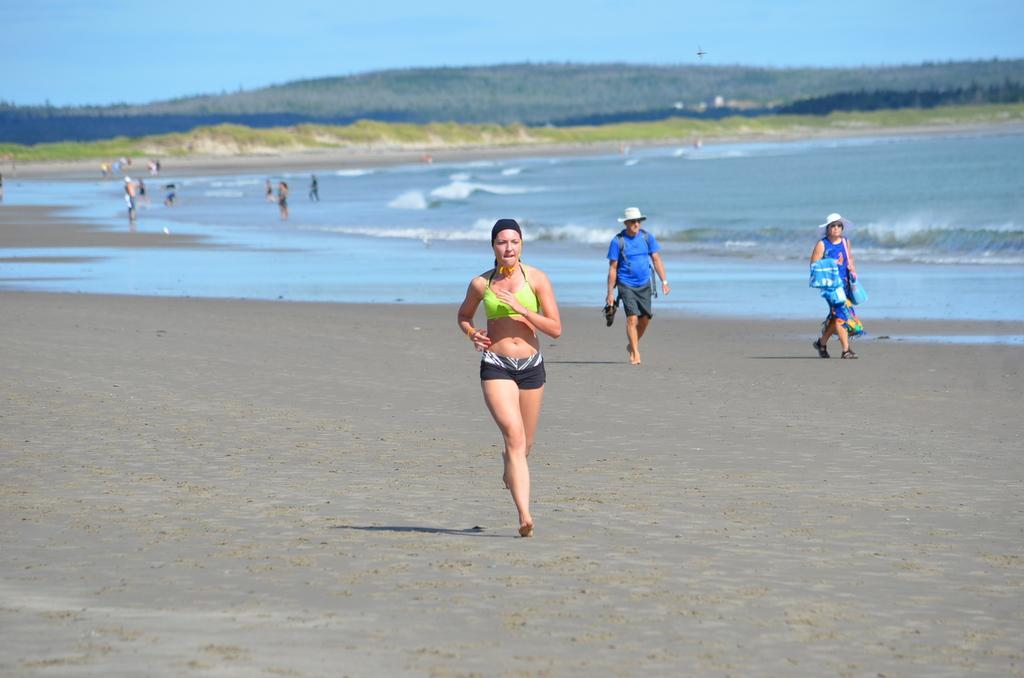How would you summarize this image in a sentence or two? Here people are walking, this is water, this is sky. 